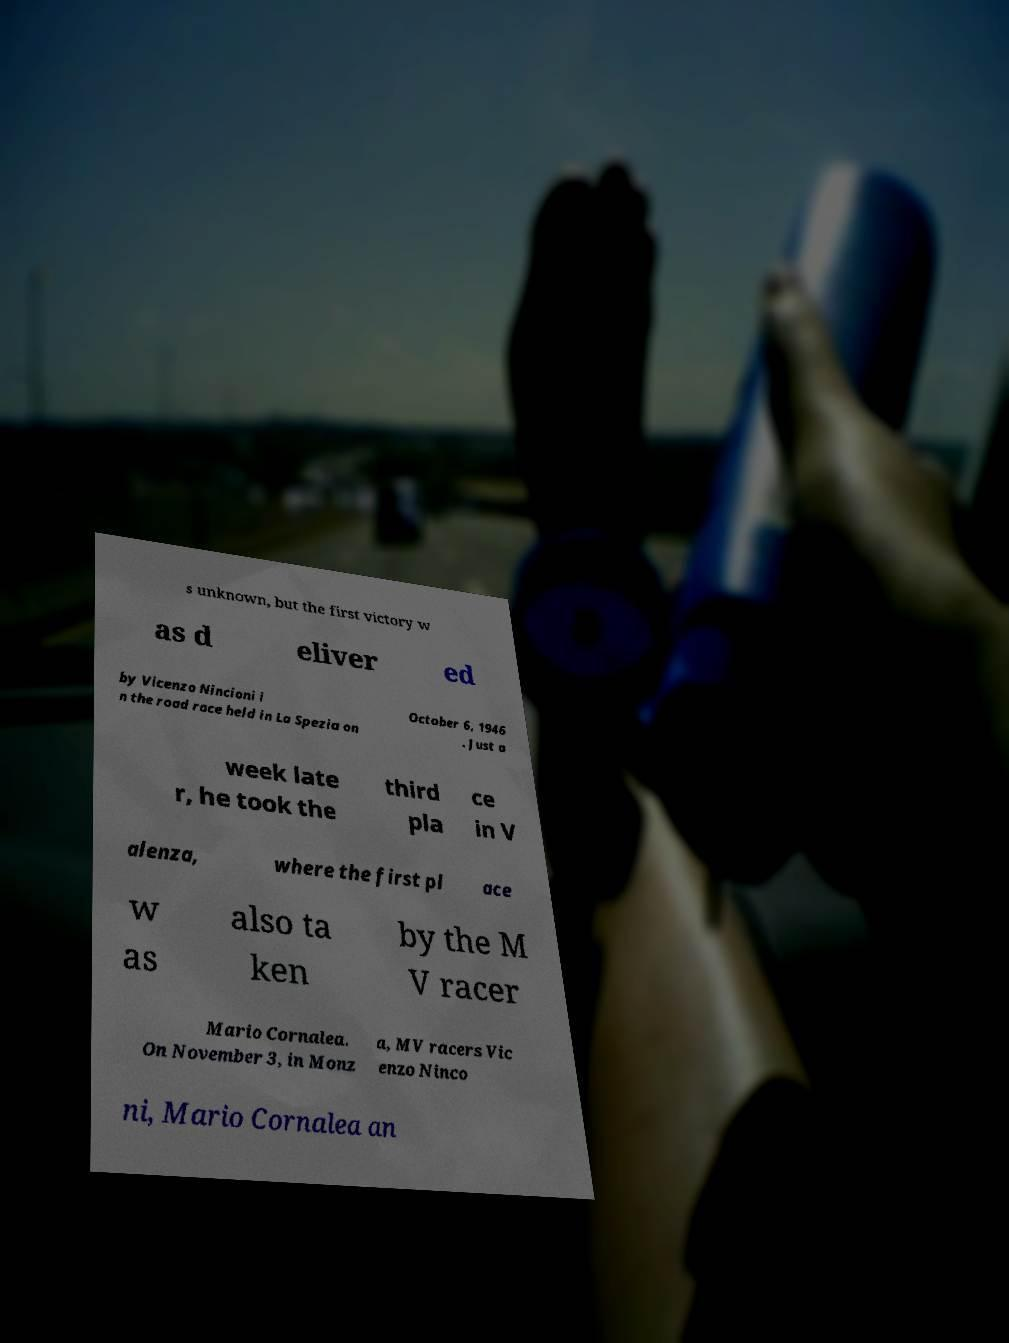There's text embedded in this image that I need extracted. Can you transcribe it verbatim? s unknown, but the first victory w as d eliver ed by Vicenzo Nincioni i n the road race held in La Spezia on October 6, 1946 . Just a week late r, he took the third pla ce in V alenza, where the first pl ace w as also ta ken by the M V racer Mario Cornalea. On November 3, in Monz a, MV racers Vic enzo Ninco ni, Mario Cornalea an 